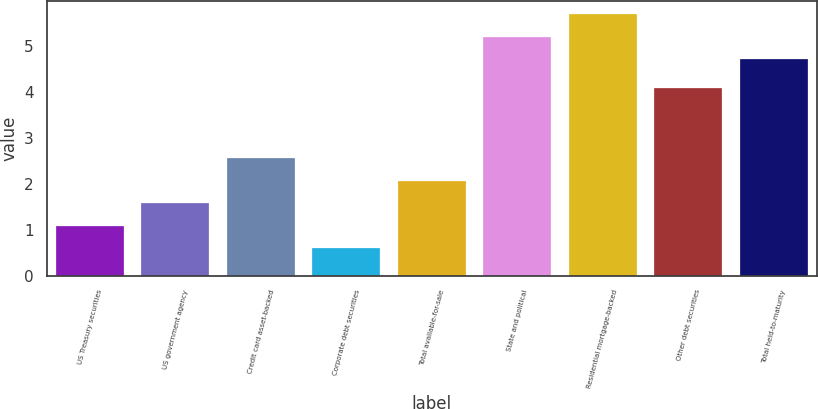Convert chart. <chart><loc_0><loc_0><loc_500><loc_500><bar_chart><fcel>US Treasury securities<fcel>US government agency<fcel>Credit card asset-backed<fcel>Corporate debt securities<fcel>Total available-for-sale<fcel>State and political<fcel>Residential mortgage-backed<fcel>Other debt securities<fcel>Total held-to-maturity<nl><fcel>1.09<fcel>1.58<fcel>2.56<fcel>0.6<fcel>2.07<fcel>5.21<fcel>5.7<fcel>4.1<fcel>4.72<nl></chart> 